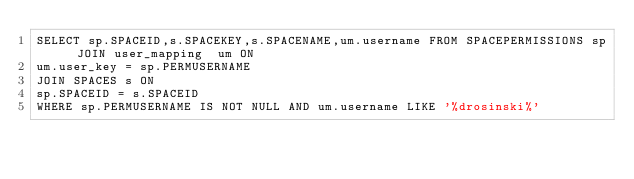Convert code to text. <code><loc_0><loc_0><loc_500><loc_500><_SQL_>SELECT sp.SPACEID,s.SPACEKEY,s.SPACENAME,um.username FROM SPACEPERMISSIONS sp JOIN user_mapping  um ON
um.user_key = sp.PERMUSERNAME
JOIN SPACES s ON 
sp.SPACEID = s.SPACEID
WHERE sp.PERMUSERNAME IS NOT NULL AND um.username LIKE '%drosinski%'

</code> 